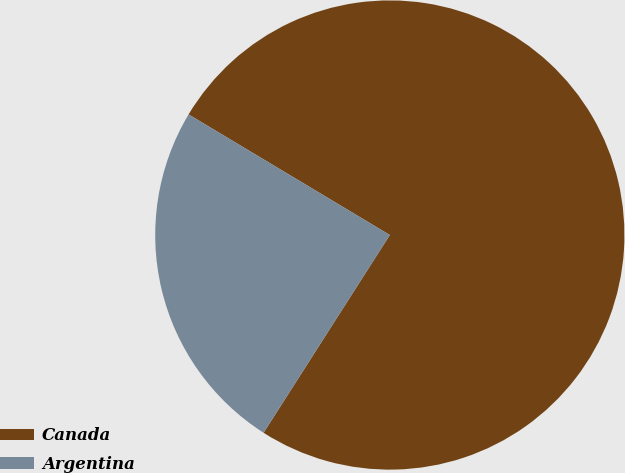Convert chart. <chart><loc_0><loc_0><loc_500><loc_500><pie_chart><fcel>Canada<fcel>Argentina<nl><fcel>75.45%<fcel>24.55%<nl></chart> 